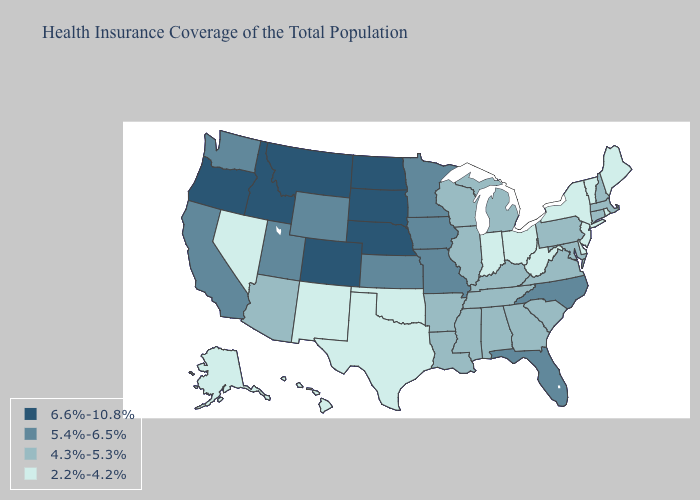What is the highest value in the USA?
Write a very short answer. 6.6%-10.8%. Name the states that have a value in the range 6.6%-10.8%?
Give a very brief answer. Colorado, Idaho, Montana, Nebraska, North Dakota, Oregon, South Dakota. Name the states that have a value in the range 5.4%-6.5%?
Concise answer only. California, Florida, Iowa, Kansas, Minnesota, Missouri, North Carolina, Utah, Washington, Wyoming. What is the highest value in the West ?
Answer briefly. 6.6%-10.8%. Which states have the lowest value in the Northeast?
Give a very brief answer. Maine, New Jersey, New York, Rhode Island, Vermont. Does Alaska have the highest value in the West?
Write a very short answer. No. Which states have the lowest value in the Northeast?
Short answer required. Maine, New Jersey, New York, Rhode Island, Vermont. Does the map have missing data?
Be succinct. No. Name the states that have a value in the range 2.2%-4.2%?
Write a very short answer. Alaska, Delaware, Hawaii, Indiana, Maine, Nevada, New Jersey, New Mexico, New York, Ohio, Oklahoma, Rhode Island, Texas, Vermont, West Virginia. Is the legend a continuous bar?
Be succinct. No. Name the states that have a value in the range 5.4%-6.5%?
Short answer required. California, Florida, Iowa, Kansas, Minnesota, Missouri, North Carolina, Utah, Washington, Wyoming. Name the states that have a value in the range 4.3%-5.3%?
Quick response, please. Alabama, Arizona, Arkansas, Connecticut, Georgia, Illinois, Kentucky, Louisiana, Maryland, Massachusetts, Michigan, Mississippi, New Hampshire, Pennsylvania, South Carolina, Tennessee, Virginia, Wisconsin. Name the states that have a value in the range 5.4%-6.5%?
Short answer required. California, Florida, Iowa, Kansas, Minnesota, Missouri, North Carolina, Utah, Washington, Wyoming. Name the states that have a value in the range 4.3%-5.3%?
Concise answer only. Alabama, Arizona, Arkansas, Connecticut, Georgia, Illinois, Kentucky, Louisiana, Maryland, Massachusetts, Michigan, Mississippi, New Hampshire, Pennsylvania, South Carolina, Tennessee, Virginia, Wisconsin. What is the value of Arkansas?
Write a very short answer. 4.3%-5.3%. 